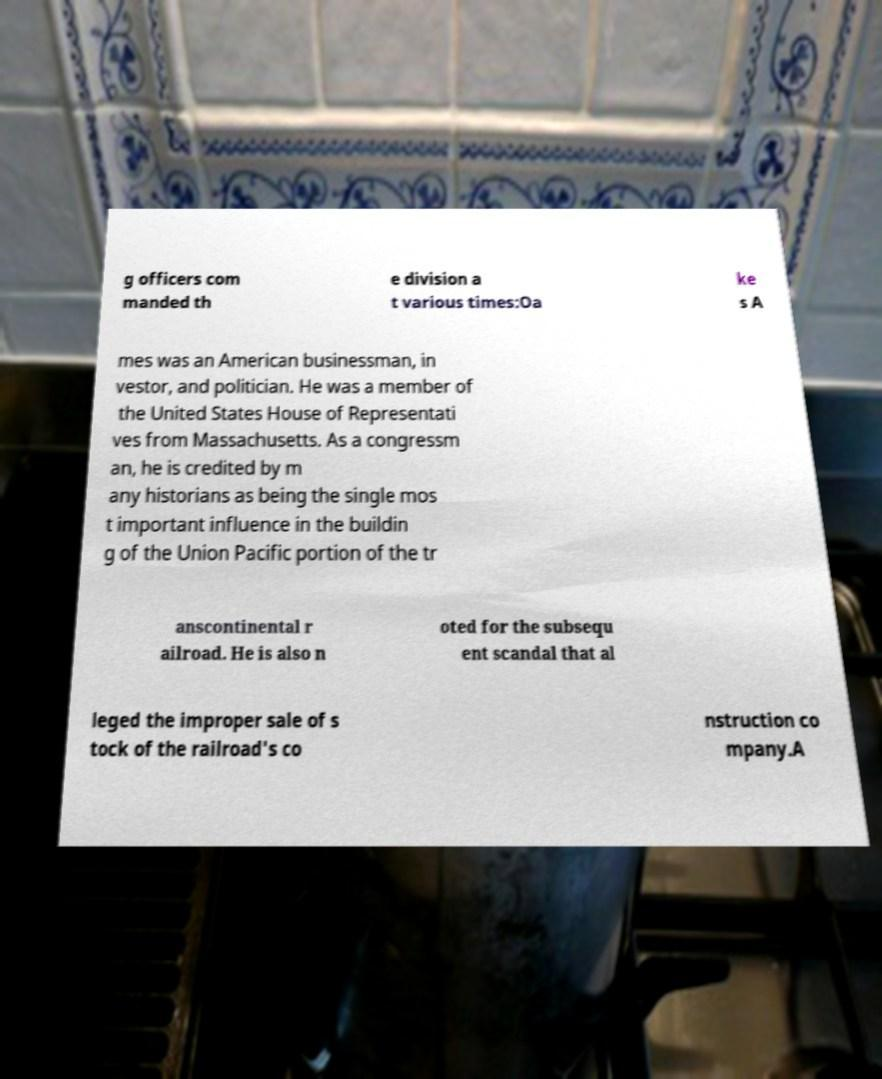There's text embedded in this image that I need extracted. Can you transcribe it verbatim? g officers com manded th e division a t various times:Oa ke s A mes was an American businessman, in vestor, and politician. He was a member of the United States House of Representati ves from Massachusetts. As a congressm an, he is credited by m any historians as being the single mos t important influence in the buildin g of the Union Pacific portion of the tr anscontinental r ailroad. He is also n oted for the subsequ ent scandal that al leged the improper sale of s tock of the railroad's co nstruction co mpany.A 